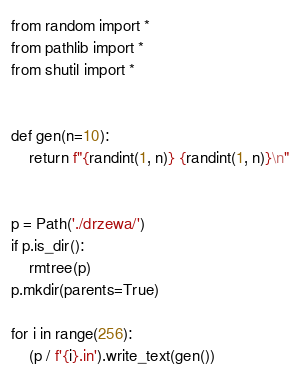<code> <loc_0><loc_0><loc_500><loc_500><_Python_>from random import *
from pathlib import *
from shutil import *


def gen(n=10):
    return f"{randint(1, n)} {randint(1, n)}\n"


p = Path('./drzewa/')
if p.is_dir():
    rmtree(p)
p.mkdir(parents=True)

for i in range(256):
    (p / f'{i}.in').write_text(gen())
</code> 